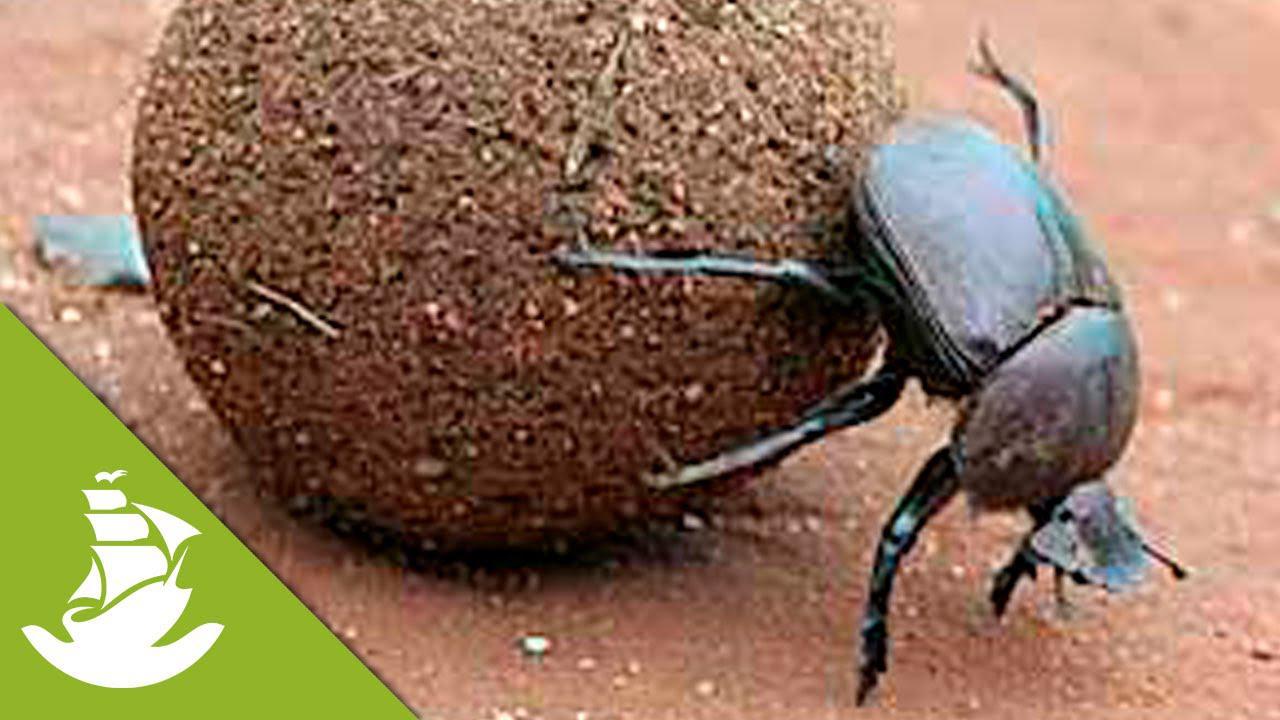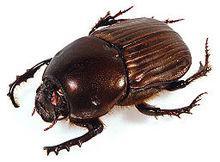The first image is the image on the left, the second image is the image on the right. Analyze the images presented: Is the assertion "One image shows a beetle but no ball, and the other image shows a beetle partly perched on a ball." valid? Answer yes or no. Yes. The first image is the image on the left, the second image is the image on the right. Analyze the images presented: Is the assertion "There is only one dungball in the image pair." valid? Answer yes or no. Yes. 